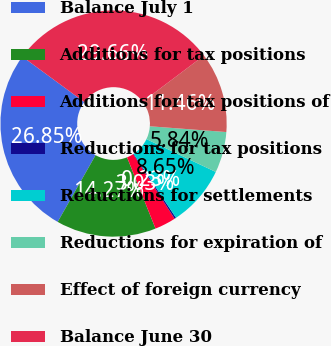Convert chart to OTSL. <chart><loc_0><loc_0><loc_500><loc_500><pie_chart><fcel>Balance July 1<fcel>Additions for tax positions<fcel>Additions for tax positions of<fcel>Reductions for tax positions<fcel>Reductions for settlements<fcel>Reductions for expiration of<fcel>Effect of foreign currency<fcel>Balance June 30<nl><fcel>26.85%<fcel>14.27%<fcel>3.03%<fcel>0.23%<fcel>8.65%<fcel>5.84%<fcel>11.46%<fcel>29.66%<nl></chart> 